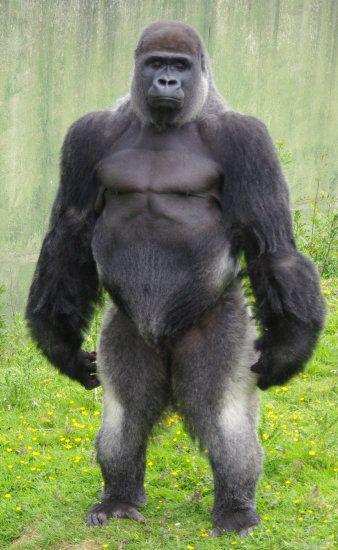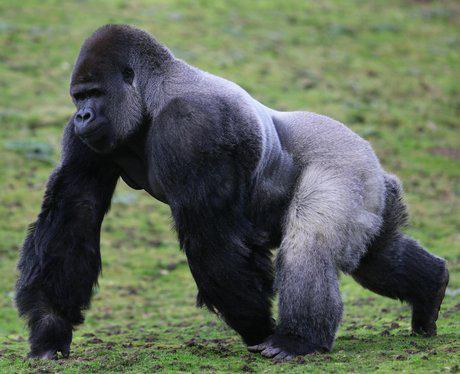The first image is the image on the left, the second image is the image on the right. Analyze the images presented: Is the assertion "A gorilla is on all fours, but without bared teeth." valid? Answer yes or no. Yes. 